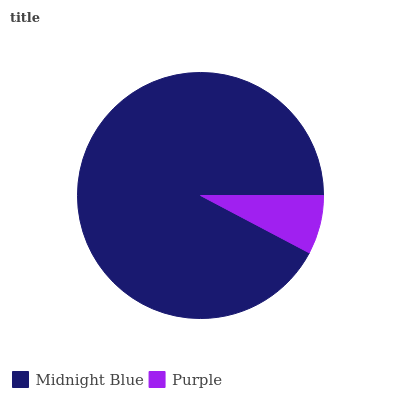Is Purple the minimum?
Answer yes or no. Yes. Is Midnight Blue the maximum?
Answer yes or no. Yes. Is Purple the maximum?
Answer yes or no. No. Is Midnight Blue greater than Purple?
Answer yes or no. Yes. Is Purple less than Midnight Blue?
Answer yes or no. Yes. Is Purple greater than Midnight Blue?
Answer yes or no. No. Is Midnight Blue less than Purple?
Answer yes or no. No. Is Midnight Blue the high median?
Answer yes or no. Yes. Is Purple the low median?
Answer yes or no. Yes. Is Purple the high median?
Answer yes or no. No. Is Midnight Blue the low median?
Answer yes or no. No. 